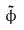Convert formula to latex. <formula><loc_0><loc_0><loc_500><loc_500>\tilde { \phi }</formula> 